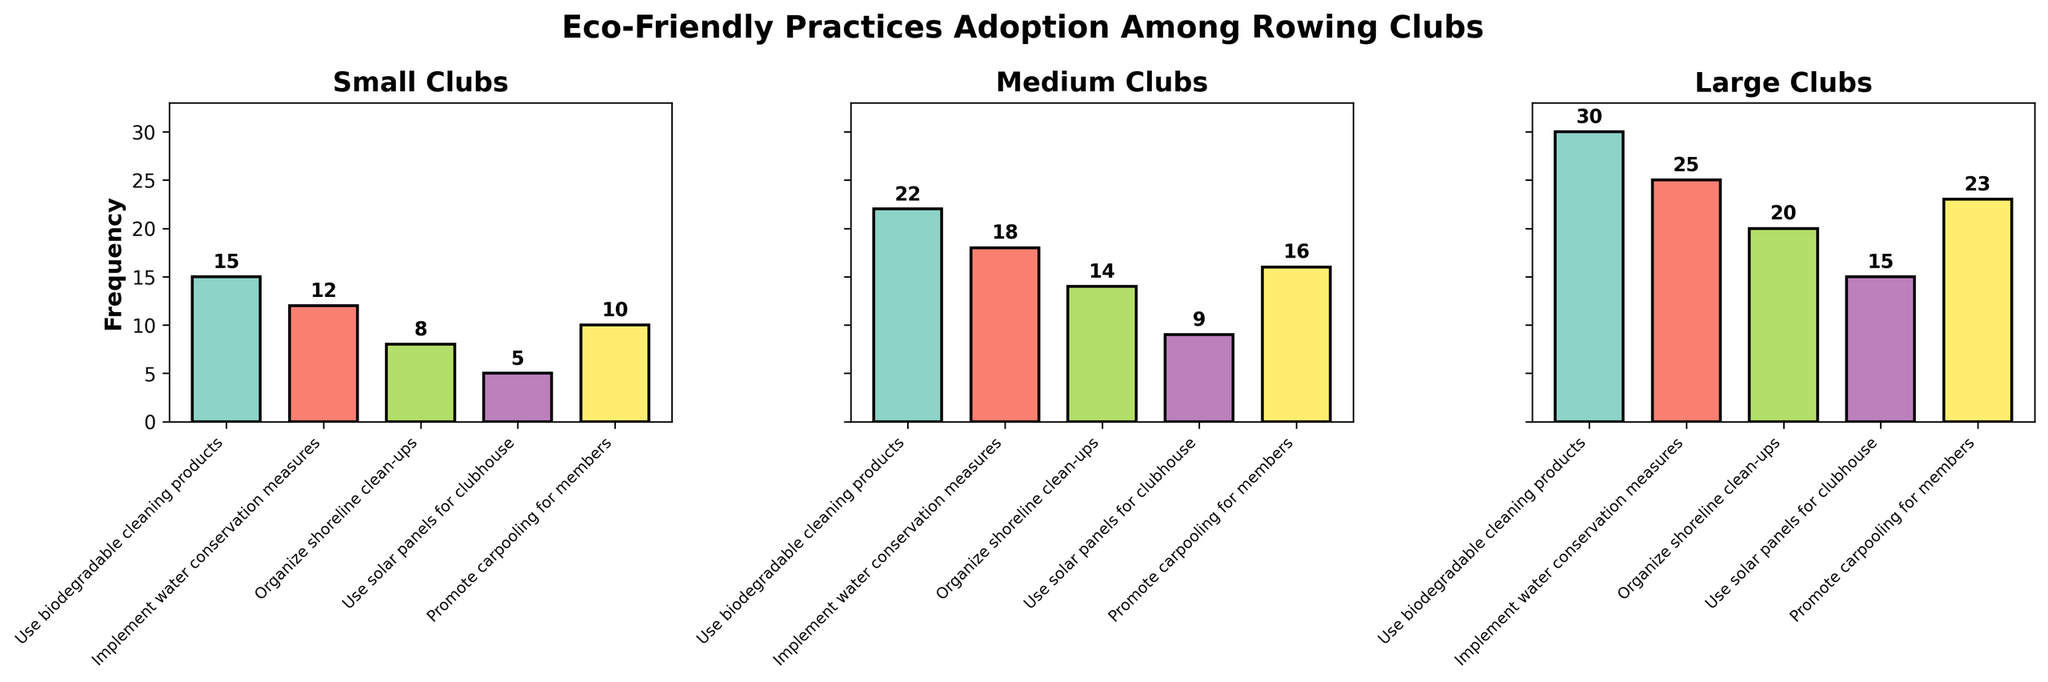What is the title of the figure? The title of the figure is usually displayed at the top of the plot. Here, it is clearly written above the subplots.
Answer: Eco-Friendly Practices Adoption Among Rowing Clubs How many eco-friendly practices are evaluated in the figure? Each subplot lists the practices on the x-axis. By counting the unique labels, we can determine the number of practices evaluated.
Answer: 5 Which club size has the highest frequency for 'Promote carpooling for members'? Look at the bars representing 'Promote carpooling for members' in all subplots and identify the one with the highest value. Here, it's the large clubs with a frequency of 23.
Answer: Large Which eco-friendly practice has the lowest adoption frequency among small clubs? Examine the frequency values of each practice for small clubs. The practice with the lowest bar corresponds to 'Use solar panels for clubhouse' which has a frequency of 5.
Answer: Use solar panels for clubhouse What is the total frequency of 'Organize shoreline clean-ups' for all club sizes combined? Add the frequencies for 'Organize shoreline clean-ups' across small, medium, and large clubs. The frequencies are 8, 14, and 20 respectively.
Answer: 42 Does the frequency of adopting 'Use biodegradable cleaning products' increase with club size? Compare the frequencies of 'Use biodegradable cleaning products' across small, medium, and large clubs. They are 15, 22, and 30, indicating an increase with club size.
Answer: Yes What is the combined frequency of all practices for medium clubs? Sum all the frequencies of medium clubs: 22 + 18 + 14 + 9 + 16.
Answer: 79 Which practice has the most consistent adoption frequency across all club sizes? Compare the adoption frequencies of each practice across the three club sizes. The one with the smallest variance indicates the most consistency. 'Use biodegradable cleaning products' varies as 15, 22, and 30. 'Implement water conservation measures' varies as 12, 18, and 25. 'Organize shoreline clean-ups' varies as 8, 14, and 20. 'Use solar panels for clubhouse' varies as 5, 9, and 15. 'Promote carpooling for members' varies as 10, 16, and 23.
Answer: Organize shoreline clean-ups How much more frequent is the adoption of 'Implement water conservation measures' in large clubs compared to small clubs? Subtract the frequency of 'Implement water conservation measures' in small clubs from that in large clubs: 25 - 12.
Answer: 13 